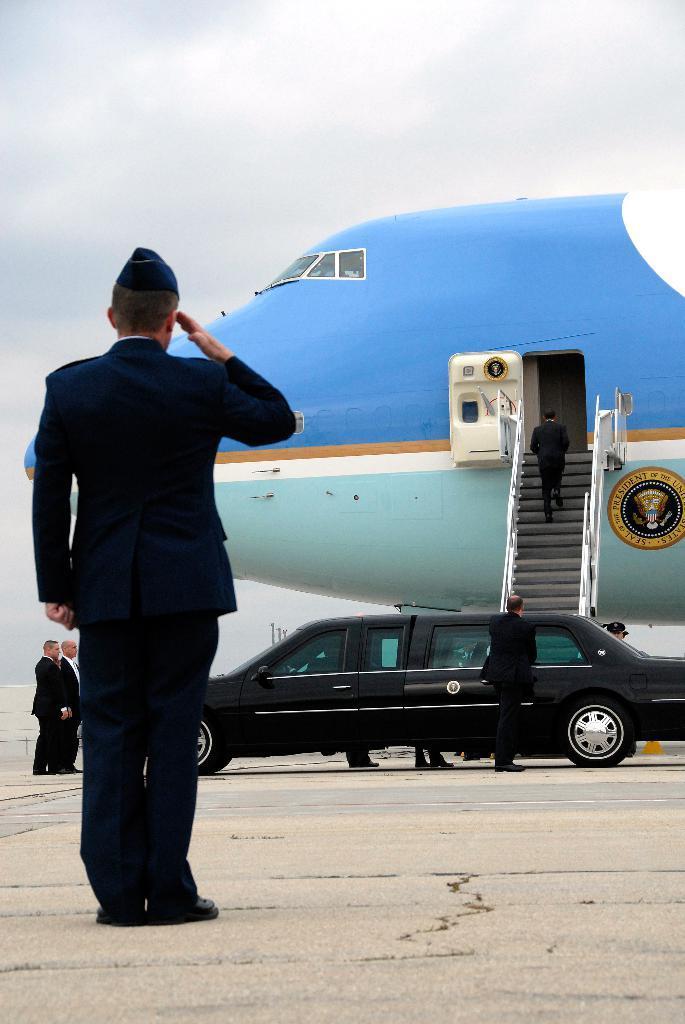How would you summarize this image in a sentence or two? On the left side, there is a person in a uniform, standing on a runway and saluting. In the background, there is a vehicle, there are persons, an airplane and there are clouds in the sky. 